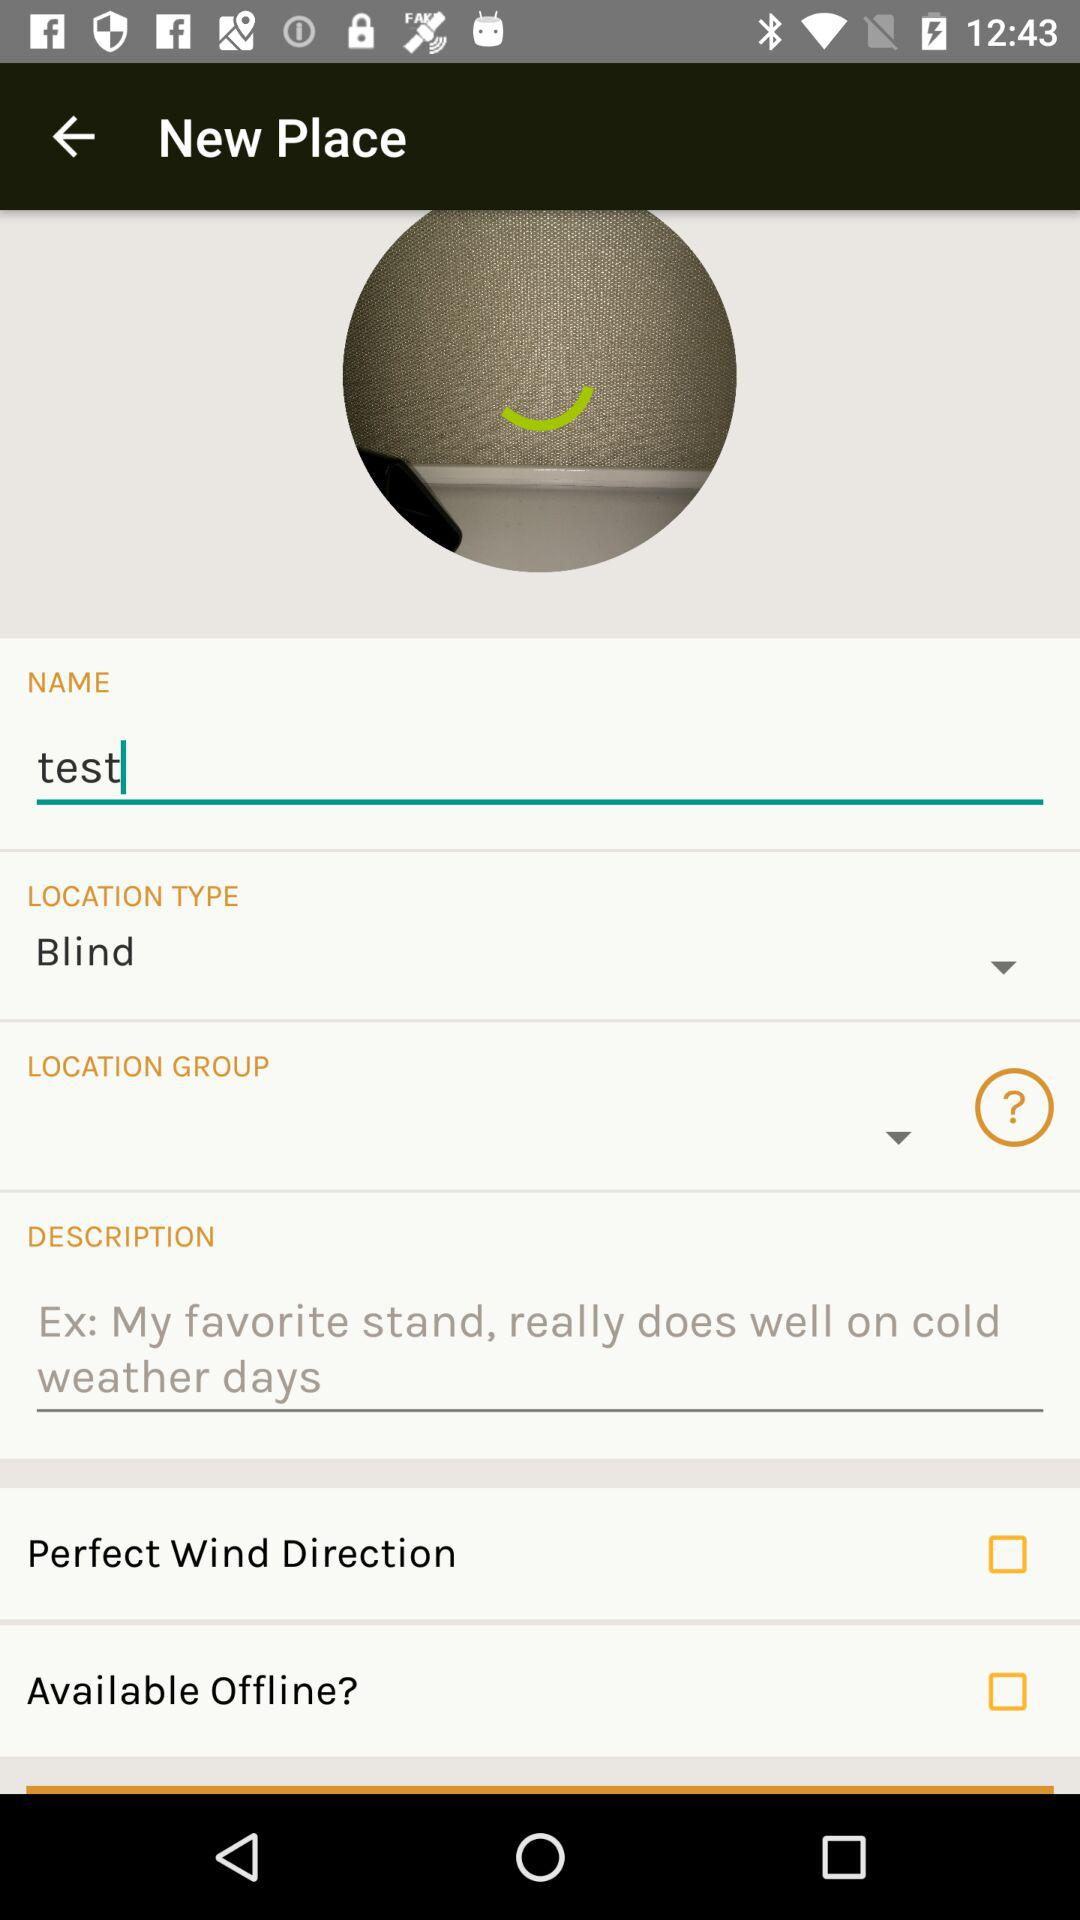What is the location type? The location type is "Blind". 